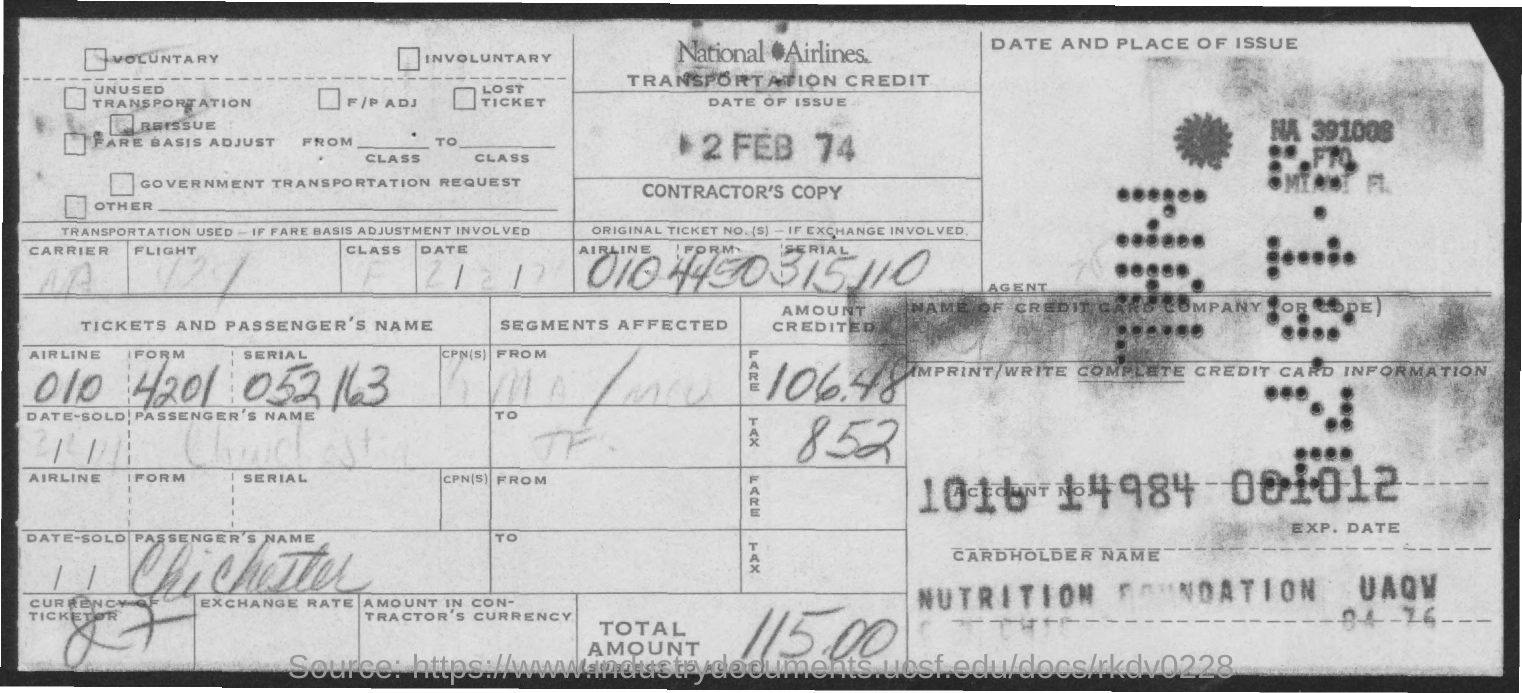Mention a couple of crucial points in this snapshot. The date of issue is February 2nd, 1974. The amount of tax is 8.52. The total amount is 115.00. National Airlines is the name of the airlines. 